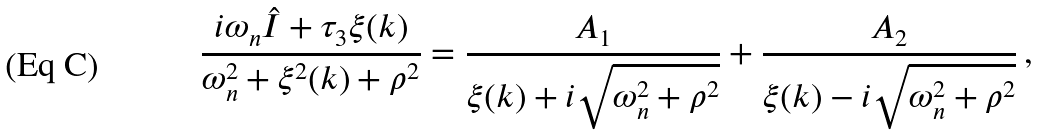<formula> <loc_0><loc_0><loc_500><loc_500>\frac { i \omega _ { n } { \hat { I } } + \tau _ { 3 } \xi ( { k } ) } { \omega _ { n } ^ { 2 } + \xi ^ { 2 } ( k ) + \rho ^ { 2 } } = \frac { A _ { 1 } } { \xi ( { k } ) + i \sqrt { \omega _ { n } ^ { 2 } + \rho ^ { 2 } } } + \frac { A _ { 2 } } { \xi ( { k } ) - i \sqrt { \omega _ { n } ^ { 2 } + \rho ^ { 2 } } } \, ,</formula> 